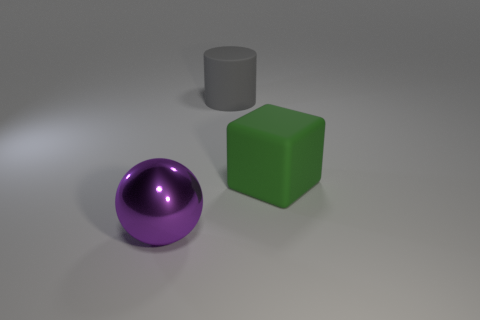Add 3 small blue metal cylinders. How many objects exist? 6 Subtract all spheres. How many objects are left? 2 Subtract all tiny purple cylinders. Subtract all large purple things. How many objects are left? 2 Add 2 matte cylinders. How many matte cylinders are left? 3 Add 2 matte things. How many matte things exist? 4 Subtract 0 purple blocks. How many objects are left? 3 